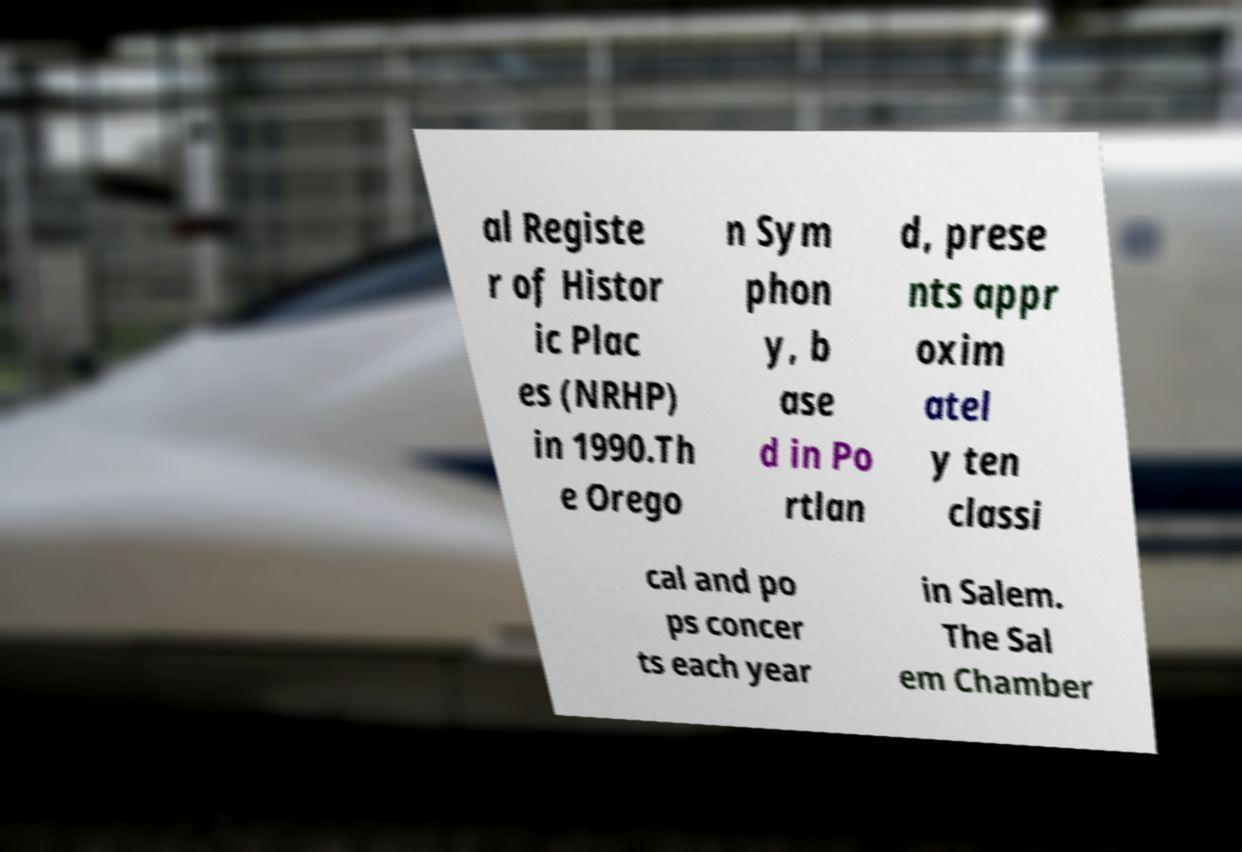I need the written content from this picture converted into text. Can you do that? al Registe r of Histor ic Plac es (NRHP) in 1990.Th e Orego n Sym phon y, b ase d in Po rtlan d, prese nts appr oxim atel y ten classi cal and po ps concer ts each year in Salem. The Sal em Chamber 